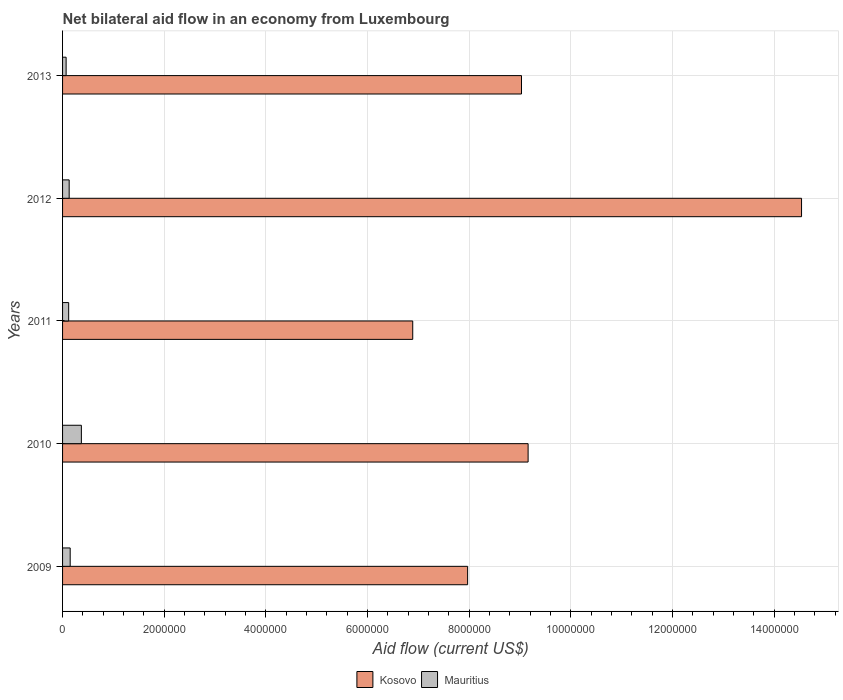How many different coloured bars are there?
Provide a succinct answer. 2. How many groups of bars are there?
Provide a succinct answer. 5. Are the number of bars on each tick of the Y-axis equal?
Provide a succinct answer. Yes. How many bars are there on the 1st tick from the bottom?
Keep it short and to the point. 2. What is the label of the 3rd group of bars from the top?
Provide a short and direct response. 2011. What is the net bilateral aid flow in Mauritius in 2010?
Provide a succinct answer. 3.70e+05. Across all years, what is the maximum net bilateral aid flow in Kosovo?
Provide a succinct answer. 1.45e+07. In which year was the net bilateral aid flow in Mauritius maximum?
Ensure brevity in your answer.  2010. In which year was the net bilateral aid flow in Mauritius minimum?
Your answer should be very brief. 2013. What is the total net bilateral aid flow in Kosovo in the graph?
Your response must be concise. 4.76e+07. What is the difference between the net bilateral aid flow in Kosovo in 2009 and that in 2010?
Provide a short and direct response. -1.19e+06. What is the difference between the net bilateral aid flow in Mauritius in 2009 and the net bilateral aid flow in Kosovo in 2013?
Your response must be concise. -8.88e+06. What is the average net bilateral aid flow in Mauritius per year?
Ensure brevity in your answer.  1.68e+05. In the year 2011, what is the difference between the net bilateral aid flow in Mauritius and net bilateral aid flow in Kosovo?
Your response must be concise. -6.77e+06. What is the ratio of the net bilateral aid flow in Kosovo in 2011 to that in 2013?
Provide a succinct answer. 0.76. Is the net bilateral aid flow in Mauritius in 2012 less than that in 2013?
Your answer should be compact. No. What is the difference between the highest and the second highest net bilateral aid flow in Kosovo?
Ensure brevity in your answer.  5.38e+06. What is the difference between the highest and the lowest net bilateral aid flow in Kosovo?
Offer a terse response. 7.65e+06. In how many years, is the net bilateral aid flow in Mauritius greater than the average net bilateral aid flow in Mauritius taken over all years?
Your answer should be very brief. 1. What does the 1st bar from the top in 2009 represents?
Give a very brief answer. Mauritius. What does the 2nd bar from the bottom in 2009 represents?
Offer a terse response. Mauritius. How many bars are there?
Make the answer very short. 10. Are all the bars in the graph horizontal?
Provide a short and direct response. Yes. How many years are there in the graph?
Provide a short and direct response. 5. What is the difference between two consecutive major ticks on the X-axis?
Keep it short and to the point. 2.00e+06. Does the graph contain any zero values?
Your answer should be very brief. No. How many legend labels are there?
Your answer should be very brief. 2. How are the legend labels stacked?
Ensure brevity in your answer.  Horizontal. What is the title of the graph?
Ensure brevity in your answer.  Net bilateral aid flow in an economy from Luxembourg. Does "United States" appear as one of the legend labels in the graph?
Make the answer very short. No. What is the label or title of the Y-axis?
Keep it short and to the point. Years. What is the Aid flow (current US$) of Kosovo in 2009?
Your response must be concise. 7.97e+06. What is the Aid flow (current US$) in Kosovo in 2010?
Make the answer very short. 9.16e+06. What is the Aid flow (current US$) in Kosovo in 2011?
Ensure brevity in your answer.  6.89e+06. What is the Aid flow (current US$) of Kosovo in 2012?
Offer a terse response. 1.45e+07. What is the Aid flow (current US$) in Kosovo in 2013?
Your answer should be very brief. 9.03e+06. What is the Aid flow (current US$) of Mauritius in 2013?
Your answer should be very brief. 7.00e+04. Across all years, what is the maximum Aid flow (current US$) in Kosovo?
Ensure brevity in your answer.  1.45e+07. Across all years, what is the minimum Aid flow (current US$) of Kosovo?
Provide a short and direct response. 6.89e+06. What is the total Aid flow (current US$) in Kosovo in the graph?
Ensure brevity in your answer.  4.76e+07. What is the total Aid flow (current US$) in Mauritius in the graph?
Make the answer very short. 8.40e+05. What is the difference between the Aid flow (current US$) in Kosovo in 2009 and that in 2010?
Ensure brevity in your answer.  -1.19e+06. What is the difference between the Aid flow (current US$) in Kosovo in 2009 and that in 2011?
Your response must be concise. 1.08e+06. What is the difference between the Aid flow (current US$) in Mauritius in 2009 and that in 2011?
Offer a terse response. 3.00e+04. What is the difference between the Aid flow (current US$) in Kosovo in 2009 and that in 2012?
Your response must be concise. -6.57e+06. What is the difference between the Aid flow (current US$) in Mauritius in 2009 and that in 2012?
Keep it short and to the point. 2.00e+04. What is the difference between the Aid flow (current US$) of Kosovo in 2009 and that in 2013?
Give a very brief answer. -1.06e+06. What is the difference between the Aid flow (current US$) in Mauritius in 2009 and that in 2013?
Keep it short and to the point. 8.00e+04. What is the difference between the Aid flow (current US$) of Kosovo in 2010 and that in 2011?
Give a very brief answer. 2.27e+06. What is the difference between the Aid flow (current US$) of Kosovo in 2010 and that in 2012?
Offer a terse response. -5.38e+06. What is the difference between the Aid flow (current US$) of Mauritius in 2010 and that in 2012?
Provide a succinct answer. 2.40e+05. What is the difference between the Aid flow (current US$) in Mauritius in 2010 and that in 2013?
Offer a terse response. 3.00e+05. What is the difference between the Aid flow (current US$) of Kosovo in 2011 and that in 2012?
Make the answer very short. -7.65e+06. What is the difference between the Aid flow (current US$) in Kosovo in 2011 and that in 2013?
Provide a short and direct response. -2.14e+06. What is the difference between the Aid flow (current US$) in Kosovo in 2012 and that in 2013?
Give a very brief answer. 5.51e+06. What is the difference between the Aid flow (current US$) of Kosovo in 2009 and the Aid flow (current US$) of Mauritius in 2010?
Offer a terse response. 7.60e+06. What is the difference between the Aid flow (current US$) of Kosovo in 2009 and the Aid flow (current US$) of Mauritius in 2011?
Offer a terse response. 7.85e+06. What is the difference between the Aid flow (current US$) in Kosovo in 2009 and the Aid flow (current US$) in Mauritius in 2012?
Offer a terse response. 7.84e+06. What is the difference between the Aid flow (current US$) of Kosovo in 2009 and the Aid flow (current US$) of Mauritius in 2013?
Keep it short and to the point. 7.90e+06. What is the difference between the Aid flow (current US$) in Kosovo in 2010 and the Aid flow (current US$) in Mauritius in 2011?
Offer a terse response. 9.04e+06. What is the difference between the Aid flow (current US$) of Kosovo in 2010 and the Aid flow (current US$) of Mauritius in 2012?
Your response must be concise. 9.03e+06. What is the difference between the Aid flow (current US$) of Kosovo in 2010 and the Aid flow (current US$) of Mauritius in 2013?
Your answer should be very brief. 9.09e+06. What is the difference between the Aid flow (current US$) of Kosovo in 2011 and the Aid flow (current US$) of Mauritius in 2012?
Your response must be concise. 6.76e+06. What is the difference between the Aid flow (current US$) in Kosovo in 2011 and the Aid flow (current US$) in Mauritius in 2013?
Offer a very short reply. 6.82e+06. What is the difference between the Aid flow (current US$) in Kosovo in 2012 and the Aid flow (current US$) in Mauritius in 2013?
Your answer should be very brief. 1.45e+07. What is the average Aid flow (current US$) of Kosovo per year?
Offer a very short reply. 9.52e+06. What is the average Aid flow (current US$) in Mauritius per year?
Your answer should be compact. 1.68e+05. In the year 2009, what is the difference between the Aid flow (current US$) in Kosovo and Aid flow (current US$) in Mauritius?
Your response must be concise. 7.82e+06. In the year 2010, what is the difference between the Aid flow (current US$) in Kosovo and Aid flow (current US$) in Mauritius?
Your response must be concise. 8.79e+06. In the year 2011, what is the difference between the Aid flow (current US$) in Kosovo and Aid flow (current US$) in Mauritius?
Give a very brief answer. 6.77e+06. In the year 2012, what is the difference between the Aid flow (current US$) in Kosovo and Aid flow (current US$) in Mauritius?
Your answer should be compact. 1.44e+07. In the year 2013, what is the difference between the Aid flow (current US$) in Kosovo and Aid flow (current US$) in Mauritius?
Your response must be concise. 8.96e+06. What is the ratio of the Aid flow (current US$) in Kosovo in 2009 to that in 2010?
Offer a terse response. 0.87. What is the ratio of the Aid flow (current US$) in Mauritius in 2009 to that in 2010?
Your answer should be very brief. 0.41. What is the ratio of the Aid flow (current US$) in Kosovo in 2009 to that in 2011?
Your answer should be compact. 1.16. What is the ratio of the Aid flow (current US$) in Kosovo in 2009 to that in 2012?
Ensure brevity in your answer.  0.55. What is the ratio of the Aid flow (current US$) in Mauritius in 2009 to that in 2012?
Offer a very short reply. 1.15. What is the ratio of the Aid flow (current US$) in Kosovo in 2009 to that in 2013?
Provide a succinct answer. 0.88. What is the ratio of the Aid flow (current US$) of Mauritius in 2009 to that in 2013?
Ensure brevity in your answer.  2.14. What is the ratio of the Aid flow (current US$) of Kosovo in 2010 to that in 2011?
Provide a succinct answer. 1.33. What is the ratio of the Aid flow (current US$) of Mauritius in 2010 to that in 2011?
Keep it short and to the point. 3.08. What is the ratio of the Aid flow (current US$) of Kosovo in 2010 to that in 2012?
Offer a very short reply. 0.63. What is the ratio of the Aid flow (current US$) in Mauritius in 2010 to that in 2012?
Provide a short and direct response. 2.85. What is the ratio of the Aid flow (current US$) of Kosovo in 2010 to that in 2013?
Ensure brevity in your answer.  1.01. What is the ratio of the Aid flow (current US$) of Mauritius in 2010 to that in 2013?
Make the answer very short. 5.29. What is the ratio of the Aid flow (current US$) in Kosovo in 2011 to that in 2012?
Your answer should be compact. 0.47. What is the ratio of the Aid flow (current US$) of Mauritius in 2011 to that in 2012?
Your answer should be compact. 0.92. What is the ratio of the Aid flow (current US$) of Kosovo in 2011 to that in 2013?
Give a very brief answer. 0.76. What is the ratio of the Aid flow (current US$) in Mauritius in 2011 to that in 2013?
Keep it short and to the point. 1.71. What is the ratio of the Aid flow (current US$) in Kosovo in 2012 to that in 2013?
Give a very brief answer. 1.61. What is the ratio of the Aid flow (current US$) in Mauritius in 2012 to that in 2013?
Your response must be concise. 1.86. What is the difference between the highest and the second highest Aid flow (current US$) in Kosovo?
Provide a succinct answer. 5.38e+06. What is the difference between the highest and the lowest Aid flow (current US$) in Kosovo?
Offer a terse response. 7.65e+06. 